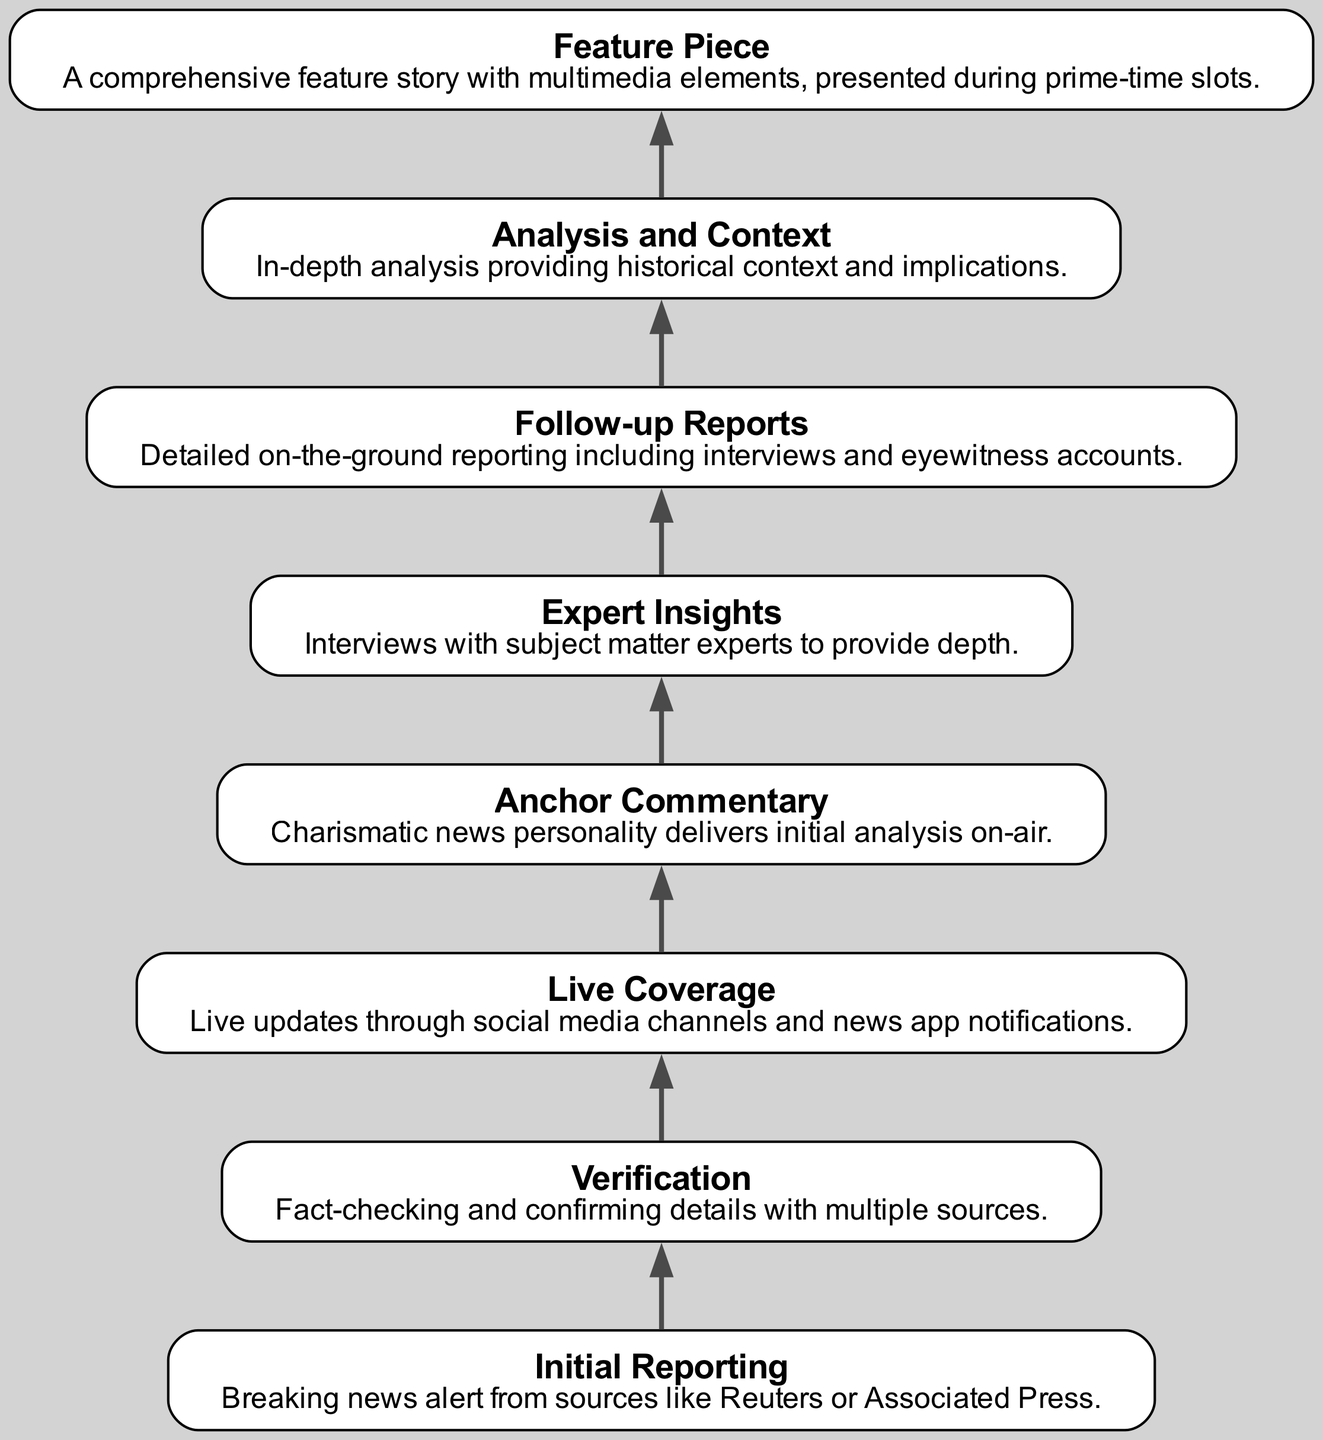What is the first stage in the evolution of a news story? The first node in the diagram represents "Initial Reporting," which is the beginning stage where breaking news alerts are received.
Answer: Initial Reporting How many nodes are in the diagram? Counting all the elements provided in the diagram, there are a total of eight nodes ranging from Initial Reporting to Feature Piece.
Answer: 8 What does the node before "Expert Insights" represent? In the flow chart, the node immediately preceding "Expert Insights" is "Anchor Commentary," which is where the news personality delivers their initial analysis.
Answer: Anchor Commentary Which stage comes directly after "Verification"? Following "Verification" in the flow chart is "Live Coverage," indicating the transition to providing immediate updates through various channels.
Answer: Live Coverage What is the last step in the evolution of a news story? The final node in this evolution process is "Feature Piece," signifying the comprehensive story presented with multimedia elements.
Answer: Feature Piece What role do "Follow-up Reports" play in the process? "Follow-up Reports" provide detailed on-the-ground reporting that includes interviews and eyewitness accounts after the initial stages of coverage.
Answer: Detailed on-the-ground reporting How many connections are present between the nodes in the diagram? Each node (except the first) is connected to the node above it leading to seven edges that connect all eight nodes in a linear flow.
Answer: 7 What function is represented by the transition from "Analysis and Context" to "Feature Piece"? The transition indicates that detailed analysis contributes to the creation of a comprehensive feature story, enhancing the depth of the final product.
Answer: Comprehensive feature story 